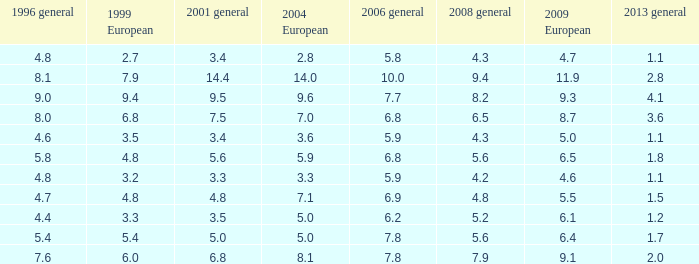What was the value for 2004 European with less than 7.5 in general 2001, less than 6.4 in 2009 European, and less than 1.5 in general 2013 with 4.3 in 2008 general? 3.6, 2.8. 